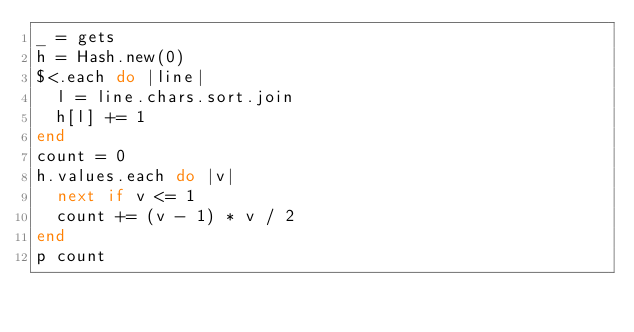<code> <loc_0><loc_0><loc_500><loc_500><_Ruby_>_ = gets
h = Hash.new(0)
$<.each do |line|
  l = line.chars.sort.join
  h[l] += 1
end
count = 0
h.values.each do |v|
  next if v <= 1
  count += (v - 1) * v / 2
end
p count</code> 